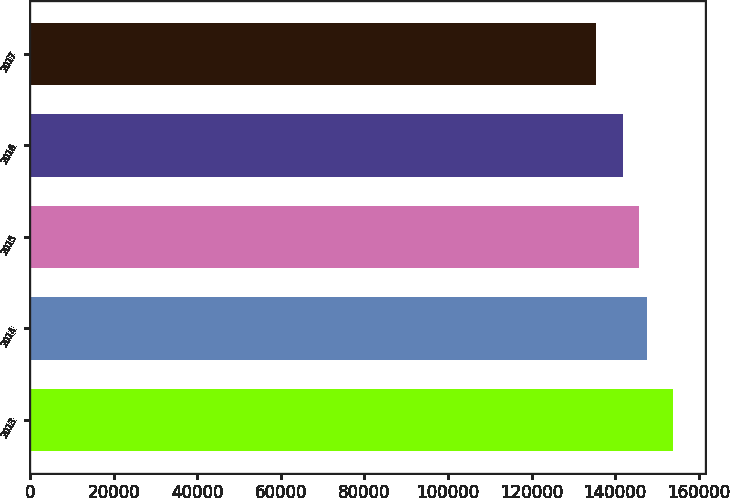<chart> <loc_0><loc_0><loc_500><loc_500><bar_chart><fcel>2013<fcel>2014<fcel>2015<fcel>2016<fcel>2017<nl><fcel>153823<fcel>147601<fcel>145757<fcel>141829<fcel>135382<nl></chart> 